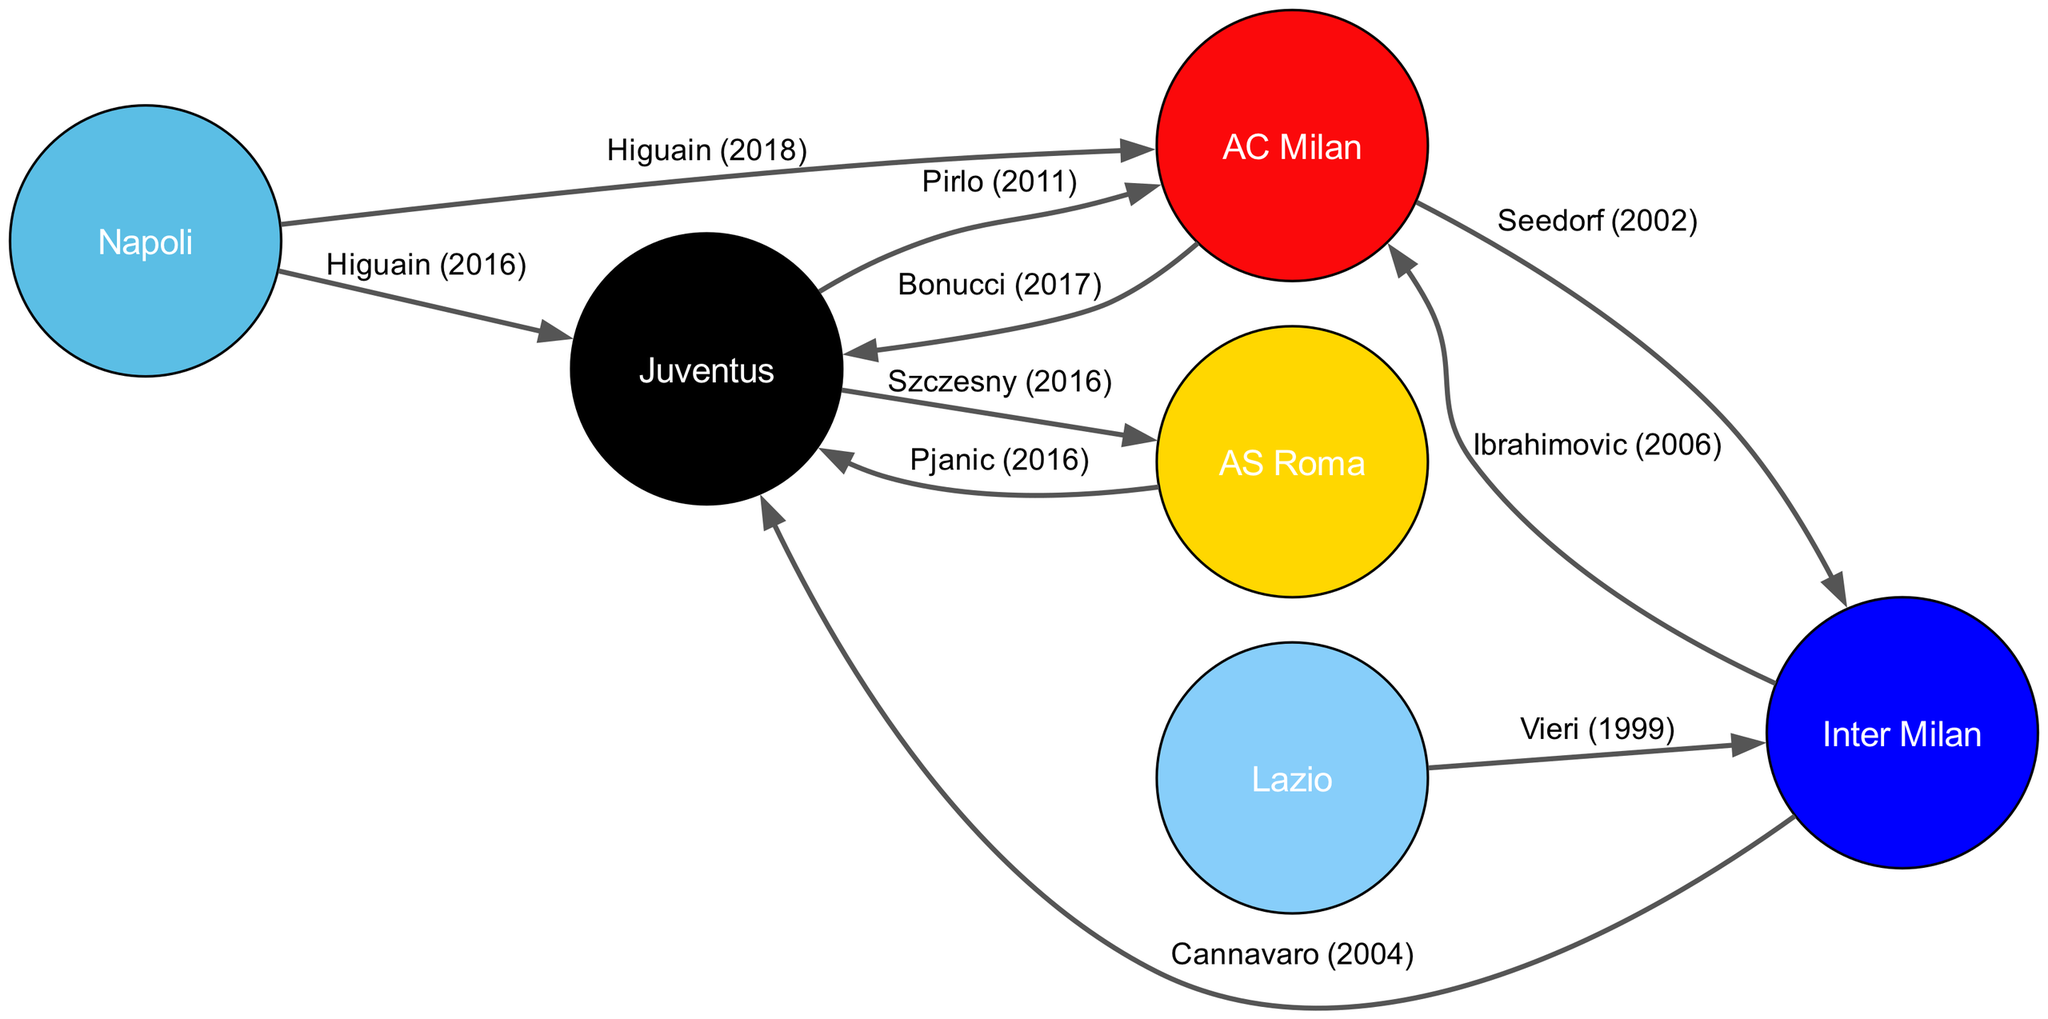What clubs are represented in the diagram? The diagram contains nodes representing six top Serie A clubs: Juventus, AC Milan, Inter Milan, AS Roma, Napoli, and Lazio. Each node corresponds to one club, visually placed in the diagram.
Answer: Juventus, AC Milan, Inter Milan, AS Roma, Napoli, Lazio How many edges are present in the diagram? The diagram consists of eight directed edges, each representing a player transfer between the clubs. These edges are identifiable as arrows connecting the nodes, with each edge labeled with the player's name and transfer year.
Answer: 8 Which player transferred from AC Milan to Juventus? The edge directed from AC Milan to Juventus is labeled with "Bonucci (2017)", indicating that Bonucci was the player who transferred from AC Milan to Juventus in that year.
Answer: Bonucci What is the earliest transfer shown in the diagram? By examining the edges, the earliest transfer date listed is "Vieri (1999)", which is the transfer from Lazio to Inter Milan. This can be determined by reviewing the year associated with each edge.
Answer: Vieri (1999) Which club is the most prominent in terms of incoming player transfers? Juventus has multiple incoming transfers represented as edges from AC Milan, Inter Milan, AS Roma, and Napoli, indicating that it is the most prominent club in terms of incoming transfers in this network analysis.
Answer: Juventus How many players transferred between Juventus and AS Roma? There is one edge connecting Juventus and AS Roma, labeled with "Szczesny (2016)", indicating that Szczesny is the only player who transferred between these two clubs in the diagram's timeframe.
Answer: 1 Which two clubs had a player transfer in the same year in the diagram? The edge labeled "Higuain (2016)" connects Napoli to Juventus, and the edge labeled "Pjanic (2016)" connects AS Roma to Juventus. Both transfers occurred in the year 2016, thus indicating that two clubs transferred players to Juventus that same year.
Answer: Napoli and AS Roma Is there any direct transfer from Napoli to Inter Milan in the diagram? No, there is no direct edge or transfer depicted from Napoli to Inter Milan in the diagram. The edges show transfers only to Juventus and AC Milan from Napoli, confirming no direct link exists.
Answer: No 